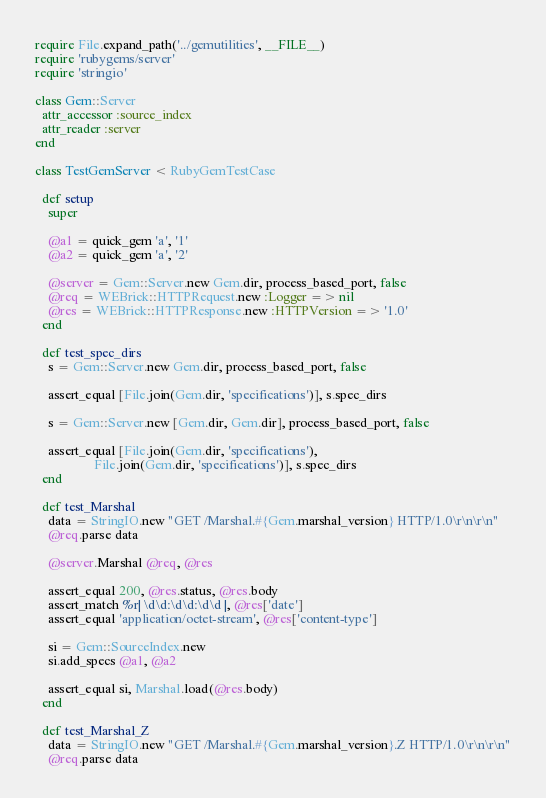<code> <loc_0><loc_0><loc_500><loc_500><_Ruby_>require File.expand_path('../gemutilities', __FILE__)
require 'rubygems/server'
require 'stringio'

class Gem::Server
  attr_accessor :source_index
  attr_reader :server
end

class TestGemServer < RubyGemTestCase

  def setup
    super

    @a1 = quick_gem 'a', '1'
    @a2 = quick_gem 'a', '2'

    @server = Gem::Server.new Gem.dir, process_based_port, false
    @req = WEBrick::HTTPRequest.new :Logger => nil
    @res = WEBrick::HTTPResponse.new :HTTPVersion => '1.0'
  end

  def test_spec_dirs
    s = Gem::Server.new Gem.dir, process_based_port, false

    assert_equal [File.join(Gem.dir, 'specifications')], s.spec_dirs

    s = Gem::Server.new [Gem.dir, Gem.dir], process_based_port, false

    assert_equal [File.join(Gem.dir, 'specifications'),
                  File.join(Gem.dir, 'specifications')], s.spec_dirs
  end

  def test_Marshal
    data = StringIO.new "GET /Marshal.#{Gem.marshal_version} HTTP/1.0\r\n\r\n"
    @req.parse data

    @server.Marshal @req, @res

    assert_equal 200, @res.status, @res.body
    assert_match %r| \d\d:\d\d:\d\d |, @res['date']
    assert_equal 'application/octet-stream', @res['content-type']

    si = Gem::SourceIndex.new
    si.add_specs @a1, @a2

    assert_equal si, Marshal.load(@res.body)
  end

  def test_Marshal_Z
    data = StringIO.new "GET /Marshal.#{Gem.marshal_version}.Z HTTP/1.0\r\n\r\n"
    @req.parse data
</code> 